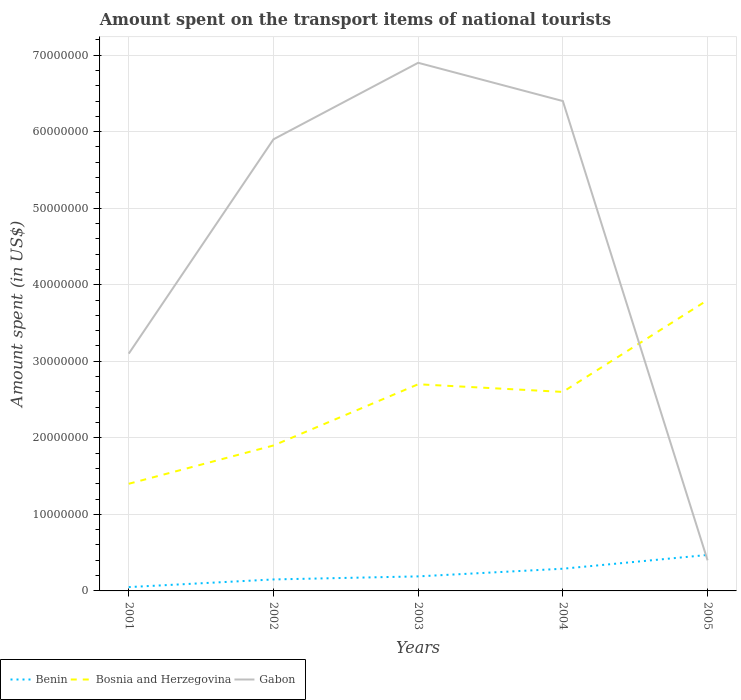How many different coloured lines are there?
Make the answer very short. 3. Does the line corresponding to Benin intersect with the line corresponding to Gabon?
Your answer should be compact. Yes. What is the total amount spent on the transport items of national tourists in Benin in the graph?
Keep it short and to the point. -2.40e+06. What is the difference between the highest and the second highest amount spent on the transport items of national tourists in Benin?
Offer a very short reply. 4.20e+06. Is the amount spent on the transport items of national tourists in Gabon strictly greater than the amount spent on the transport items of national tourists in Benin over the years?
Keep it short and to the point. No. How many lines are there?
Offer a very short reply. 3. How many years are there in the graph?
Offer a very short reply. 5. What is the difference between two consecutive major ticks on the Y-axis?
Give a very brief answer. 1.00e+07. Are the values on the major ticks of Y-axis written in scientific E-notation?
Keep it short and to the point. No. Does the graph contain grids?
Offer a terse response. Yes. What is the title of the graph?
Give a very brief answer. Amount spent on the transport items of national tourists. Does "Cyprus" appear as one of the legend labels in the graph?
Keep it short and to the point. No. What is the label or title of the Y-axis?
Make the answer very short. Amount spent (in US$). What is the Amount spent (in US$) in Benin in 2001?
Offer a very short reply. 5.00e+05. What is the Amount spent (in US$) of Bosnia and Herzegovina in 2001?
Make the answer very short. 1.40e+07. What is the Amount spent (in US$) in Gabon in 2001?
Your answer should be compact. 3.10e+07. What is the Amount spent (in US$) in Benin in 2002?
Give a very brief answer. 1.50e+06. What is the Amount spent (in US$) in Bosnia and Herzegovina in 2002?
Your response must be concise. 1.90e+07. What is the Amount spent (in US$) of Gabon in 2002?
Provide a short and direct response. 5.90e+07. What is the Amount spent (in US$) of Benin in 2003?
Provide a succinct answer. 1.90e+06. What is the Amount spent (in US$) of Bosnia and Herzegovina in 2003?
Your answer should be very brief. 2.70e+07. What is the Amount spent (in US$) of Gabon in 2003?
Keep it short and to the point. 6.90e+07. What is the Amount spent (in US$) in Benin in 2004?
Provide a short and direct response. 2.90e+06. What is the Amount spent (in US$) of Bosnia and Herzegovina in 2004?
Your answer should be very brief. 2.60e+07. What is the Amount spent (in US$) of Gabon in 2004?
Your answer should be compact. 6.40e+07. What is the Amount spent (in US$) of Benin in 2005?
Keep it short and to the point. 4.70e+06. What is the Amount spent (in US$) in Bosnia and Herzegovina in 2005?
Offer a terse response. 3.80e+07. What is the Amount spent (in US$) of Gabon in 2005?
Your response must be concise. 4.00e+06. Across all years, what is the maximum Amount spent (in US$) in Benin?
Make the answer very short. 4.70e+06. Across all years, what is the maximum Amount spent (in US$) in Bosnia and Herzegovina?
Provide a short and direct response. 3.80e+07. Across all years, what is the maximum Amount spent (in US$) of Gabon?
Offer a very short reply. 6.90e+07. Across all years, what is the minimum Amount spent (in US$) in Benin?
Provide a succinct answer. 5.00e+05. Across all years, what is the minimum Amount spent (in US$) in Bosnia and Herzegovina?
Give a very brief answer. 1.40e+07. Across all years, what is the minimum Amount spent (in US$) of Gabon?
Provide a succinct answer. 4.00e+06. What is the total Amount spent (in US$) in Benin in the graph?
Your answer should be compact. 1.15e+07. What is the total Amount spent (in US$) of Bosnia and Herzegovina in the graph?
Provide a short and direct response. 1.24e+08. What is the total Amount spent (in US$) of Gabon in the graph?
Ensure brevity in your answer.  2.27e+08. What is the difference between the Amount spent (in US$) of Bosnia and Herzegovina in 2001 and that in 2002?
Keep it short and to the point. -5.00e+06. What is the difference between the Amount spent (in US$) of Gabon in 2001 and that in 2002?
Offer a terse response. -2.80e+07. What is the difference between the Amount spent (in US$) of Benin in 2001 and that in 2003?
Offer a terse response. -1.40e+06. What is the difference between the Amount spent (in US$) of Bosnia and Herzegovina in 2001 and that in 2003?
Make the answer very short. -1.30e+07. What is the difference between the Amount spent (in US$) in Gabon in 2001 and that in 2003?
Ensure brevity in your answer.  -3.80e+07. What is the difference between the Amount spent (in US$) in Benin in 2001 and that in 2004?
Make the answer very short. -2.40e+06. What is the difference between the Amount spent (in US$) in Bosnia and Herzegovina in 2001 and that in 2004?
Provide a succinct answer. -1.20e+07. What is the difference between the Amount spent (in US$) of Gabon in 2001 and that in 2004?
Your answer should be compact. -3.30e+07. What is the difference between the Amount spent (in US$) of Benin in 2001 and that in 2005?
Your answer should be very brief. -4.20e+06. What is the difference between the Amount spent (in US$) of Bosnia and Herzegovina in 2001 and that in 2005?
Provide a succinct answer. -2.40e+07. What is the difference between the Amount spent (in US$) of Gabon in 2001 and that in 2005?
Offer a terse response. 2.70e+07. What is the difference between the Amount spent (in US$) in Benin in 2002 and that in 2003?
Your answer should be compact. -4.00e+05. What is the difference between the Amount spent (in US$) in Bosnia and Herzegovina in 2002 and that in 2003?
Your response must be concise. -8.00e+06. What is the difference between the Amount spent (in US$) of Gabon in 2002 and that in 2003?
Give a very brief answer. -1.00e+07. What is the difference between the Amount spent (in US$) of Benin in 2002 and that in 2004?
Provide a succinct answer. -1.40e+06. What is the difference between the Amount spent (in US$) of Bosnia and Herzegovina in 2002 and that in 2004?
Keep it short and to the point. -7.00e+06. What is the difference between the Amount spent (in US$) in Gabon in 2002 and that in 2004?
Make the answer very short. -5.00e+06. What is the difference between the Amount spent (in US$) in Benin in 2002 and that in 2005?
Provide a short and direct response. -3.20e+06. What is the difference between the Amount spent (in US$) in Bosnia and Herzegovina in 2002 and that in 2005?
Your answer should be very brief. -1.90e+07. What is the difference between the Amount spent (in US$) in Gabon in 2002 and that in 2005?
Your answer should be compact. 5.50e+07. What is the difference between the Amount spent (in US$) in Bosnia and Herzegovina in 2003 and that in 2004?
Your response must be concise. 1.00e+06. What is the difference between the Amount spent (in US$) in Gabon in 2003 and that in 2004?
Your answer should be compact. 5.00e+06. What is the difference between the Amount spent (in US$) of Benin in 2003 and that in 2005?
Your response must be concise. -2.80e+06. What is the difference between the Amount spent (in US$) in Bosnia and Herzegovina in 2003 and that in 2005?
Ensure brevity in your answer.  -1.10e+07. What is the difference between the Amount spent (in US$) in Gabon in 2003 and that in 2005?
Ensure brevity in your answer.  6.50e+07. What is the difference between the Amount spent (in US$) in Benin in 2004 and that in 2005?
Make the answer very short. -1.80e+06. What is the difference between the Amount spent (in US$) in Bosnia and Herzegovina in 2004 and that in 2005?
Give a very brief answer. -1.20e+07. What is the difference between the Amount spent (in US$) in Gabon in 2004 and that in 2005?
Your answer should be very brief. 6.00e+07. What is the difference between the Amount spent (in US$) of Benin in 2001 and the Amount spent (in US$) of Bosnia and Herzegovina in 2002?
Offer a very short reply. -1.85e+07. What is the difference between the Amount spent (in US$) in Benin in 2001 and the Amount spent (in US$) in Gabon in 2002?
Your answer should be very brief. -5.85e+07. What is the difference between the Amount spent (in US$) of Bosnia and Herzegovina in 2001 and the Amount spent (in US$) of Gabon in 2002?
Offer a terse response. -4.50e+07. What is the difference between the Amount spent (in US$) of Benin in 2001 and the Amount spent (in US$) of Bosnia and Herzegovina in 2003?
Provide a short and direct response. -2.65e+07. What is the difference between the Amount spent (in US$) in Benin in 2001 and the Amount spent (in US$) in Gabon in 2003?
Give a very brief answer. -6.85e+07. What is the difference between the Amount spent (in US$) in Bosnia and Herzegovina in 2001 and the Amount spent (in US$) in Gabon in 2003?
Provide a short and direct response. -5.50e+07. What is the difference between the Amount spent (in US$) in Benin in 2001 and the Amount spent (in US$) in Bosnia and Herzegovina in 2004?
Your response must be concise. -2.55e+07. What is the difference between the Amount spent (in US$) of Benin in 2001 and the Amount spent (in US$) of Gabon in 2004?
Ensure brevity in your answer.  -6.35e+07. What is the difference between the Amount spent (in US$) in Bosnia and Herzegovina in 2001 and the Amount spent (in US$) in Gabon in 2004?
Make the answer very short. -5.00e+07. What is the difference between the Amount spent (in US$) of Benin in 2001 and the Amount spent (in US$) of Bosnia and Herzegovina in 2005?
Offer a terse response. -3.75e+07. What is the difference between the Amount spent (in US$) in Benin in 2001 and the Amount spent (in US$) in Gabon in 2005?
Offer a very short reply. -3.50e+06. What is the difference between the Amount spent (in US$) in Bosnia and Herzegovina in 2001 and the Amount spent (in US$) in Gabon in 2005?
Offer a very short reply. 1.00e+07. What is the difference between the Amount spent (in US$) in Benin in 2002 and the Amount spent (in US$) in Bosnia and Herzegovina in 2003?
Your response must be concise. -2.55e+07. What is the difference between the Amount spent (in US$) of Benin in 2002 and the Amount spent (in US$) of Gabon in 2003?
Your response must be concise. -6.75e+07. What is the difference between the Amount spent (in US$) of Bosnia and Herzegovina in 2002 and the Amount spent (in US$) of Gabon in 2003?
Offer a very short reply. -5.00e+07. What is the difference between the Amount spent (in US$) of Benin in 2002 and the Amount spent (in US$) of Bosnia and Herzegovina in 2004?
Ensure brevity in your answer.  -2.45e+07. What is the difference between the Amount spent (in US$) of Benin in 2002 and the Amount spent (in US$) of Gabon in 2004?
Keep it short and to the point. -6.25e+07. What is the difference between the Amount spent (in US$) of Bosnia and Herzegovina in 2002 and the Amount spent (in US$) of Gabon in 2004?
Give a very brief answer. -4.50e+07. What is the difference between the Amount spent (in US$) of Benin in 2002 and the Amount spent (in US$) of Bosnia and Herzegovina in 2005?
Offer a very short reply. -3.65e+07. What is the difference between the Amount spent (in US$) of Benin in 2002 and the Amount spent (in US$) of Gabon in 2005?
Offer a terse response. -2.50e+06. What is the difference between the Amount spent (in US$) in Bosnia and Herzegovina in 2002 and the Amount spent (in US$) in Gabon in 2005?
Provide a short and direct response. 1.50e+07. What is the difference between the Amount spent (in US$) in Benin in 2003 and the Amount spent (in US$) in Bosnia and Herzegovina in 2004?
Provide a short and direct response. -2.41e+07. What is the difference between the Amount spent (in US$) in Benin in 2003 and the Amount spent (in US$) in Gabon in 2004?
Give a very brief answer. -6.21e+07. What is the difference between the Amount spent (in US$) in Bosnia and Herzegovina in 2003 and the Amount spent (in US$) in Gabon in 2004?
Keep it short and to the point. -3.70e+07. What is the difference between the Amount spent (in US$) in Benin in 2003 and the Amount spent (in US$) in Bosnia and Herzegovina in 2005?
Ensure brevity in your answer.  -3.61e+07. What is the difference between the Amount spent (in US$) in Benin in 2003 and the Amount spent (in US$) in Gabon in 2005?
Keep it short and to the point. -2.10e+06. What is the difference between the Amount spent (in US$) of Bosnia and Herzegovina in 2003 and the Amount spent (in US$) of Gabon in 2005?
Provide a succinct answer. 2.30e+07. What is the difference between the Amount spent (in US$) of Benin in 2004 and the Amount spent (in US$) of Bosnia and Herzegovina in 2005?
Your answer should be very brief. -3.51e+07. What is the difference between the Amount spent (in US$) of Benin in 2004 and the Amount spent (in US$) of Gabon in 2005?
Give a very brief answer. -1.10e+06. What is the difference between the Amount spent (in US$) in Bosnia and Herzegovina in 2004 and the Amount spent (in US$) in Gabon in 2005?
Offer a terse response. 2.20e+07. What is the average Amount spent (in US$) in Benin per year?
Offer a terse response. 2.30e+06. What is the average Amount spent (in US$) of Bosnia and Herzegovina per year?
Give a very brief answer. 2.48e+07. What is the average Amount spent (in US$) of Gabon per year?
Keep it short and to the point. 4.54e+07. In the year 2001, what is the difference between the Amount spent (in US$) of Benin and Amount spent (in US$) of Bosnia and Herzegovina?
Offer a very short reply. -1.35e+07. In the year 2001, what is the difference between the Amount spent (in US$) in Benin and Amount spent (in US$) in Gabon?
Your response must be concise. -3.05e+07. In the year 2001, what is the difference between the Amount spent (in US$) of Bosnia and Herzegovina and Amount spent (in US$) of Gabon?
Your answer should be compact. -1.70e+07. In the year 2002, what is the difference between the Amount spent (in US$) of Benin and Amount spent (in US$) of Bosnia and Herzegovina?
Ensure brevity in your answer.  -1.75e+07. In the year 2002, what is the difference between the Amount spent (in US$) in Benin and Amount spent (in US$) in Gabon?
Give a very brief answer. -5.75e+07. In the year 2002, what is the difference between the Amount spent (in US$) in Bosnia and Herzegovina and Amount spent (in US$) in Gabon?
Offer a terse response. -4.00e+07. In the year 2003, what is the difference between the Amount spent (in US$) of Benin and Amount spent (in US$) of Bosnia and Herzegovina?
Your response must be concise. -2.51e+07. In the year 2003, what is the difference between the Amount spent (in US$) in Benin and Amount spent (in US$) in Gabon?
Your answer should be very brief. -6.71e+07. In the year 2003, what is the difference between the Amount spent (in US$) of Bosnia and Herzegovina and Amount spent (in US$) of Gabon?
Your answer should be compact. -4.20e+07. In the year 2004, what is the difference between the Amount spent (in US$) in Benin and Amount spent (in US$) in Bosnia and Herzegovina?
Your answer should be very brief. -2.31e+07. In the year 2004, what is the difference between the Amount spent (in US$) of Benin and Amount spent (in US$) of Gabon?
Give a very brief answer. -6.11e+07. In the year 2004, what is the difference between the Amount spent (in US$) in Bosnia and Herzegovina and Amount spent (in US$) in Gabon?
Your answer should be compact. -3.80e+07. In the year 2005, what is the difference between the Amount spent (in US$) of Benin and Amount spent (in US$) of Bosnia and Herzegovina?
Offer a terse response. -3.33e+07. In the year 2005, what is the difference between the Amount spent (in US$) in Bosnia and Herzegovina and Amount spent (in US$) in Gabon?
Provide a succinct answer. 3.40e+07. What is the ratio of the Amount spent (in US$) in Bosnia and Herzegovina in 2001 to that in 2002?
Your answer should be very brief. 0.74. What is the ratio of the Amount spent (in US$) of Gabon in 2001 to that in 2002?
Ensure brevity in your answer.  0.53. What is the ratio of the Amount spent (in US$) in Benin in 2001 to that in 2003?
Provide a short and direct response. 0.26. What is the ratio of the Amount spent (in US$) in Bosnia and Herzegovina in 2001 to that in 2003?
Keep it short and to the point. 0.52. What is the ratio of the Amount spent (in US$) in Gabon in 2001 to that in 2003?
Keep it short and to the point. 0.45. What is the ratio of the Amount spent (in US$) in Benin in 2001 to that in 2004?
Provide a succinct answer. 0.17. What is the ratio of the Amount spent (in US$) in Bosnia and Herzegovina in 2001 to that in 2004?
Your answer should be compact. 0.54. What is the ratio of the Amount spent (in US$) of Gabon in 2001 to that in 2004?
Ensure brevity in your answer.  0.48. What is the ratio of the Amount spent (in US$) in Benin in 2001 to that in 2005?
Give a very brief answer. 0.11. What is the ratio of the Amount spent (in US$) of Bosnia and Herzegovina in 2001 to that in 2005?
Your response must be concise. 0.37. What is the ratio of the Amount spent (in US$) of Gabon in 2001 to that in 2005?
Offer a very short reply. 7.75. What is the ratio of the Amount spent (in US$) of Benin in 2002 to that in 2003?
Offer a very short reply. 0.79. What is the ratio of the Amount spent (in US$) in Bosnia and Herzegovina in 2002 to that in 2003?
Your answer should be very brief. 0.7. What is the ratio of the Amount spent (in US$) in Gabon in 2002 to that in 2003?
Offer a terse response. 0.86. What is the ratio of the Amount spent (in US$) in Benin in 2002 to that in 2004?
Provide a short and direct response. 0.52. What is the ratio of the Amount spent (in US$) of Bosnia and Herzegovina in 2002 to that in 2004?
Make the answer very short. 0.73. What is the ratio of the Amount spent (in US$) in Gabon in 2002 to that in 2004?
Ensure brevity in your answer.  0.92. What is the ratio of the Amount spent (in US$) in Benin in 2002 to that in 2005?
Keep it short and to the point. 0.32. What is the ratio of the Amount spent (in US$) of Gabon in 2002 to that in 2005?
Ensure brevity in your answer.  14.75. What is the ratio of the Amount spent (in US$) of Benin in 2003 to that in 2004?
Provide a short and direct response. 0.66. What is the ratio of the Amount spent (in US$) of Gabon in 2003 to that in 2004?
Make the answer very short. 1.08. What is the ratio of the Amount spent (in US$) in Benin in 2003 to that in 2005?
Offer a terse response. 0.4. What is the ratio of the Amount spent (in US$) in Bosnia and Herzegovina in 2003 to that in 2005?
Your answer should be very brief. 0.71. What is the ratio of the Amount spent (in US$) in Gabon in 2003 to that in 2005?
Offer a terse response. 17.25. What is the ratio of the Amount spent (in US$) in Benin in 2004 to that in 2005?
Provide a succinct answer. 0.62. What is the ratio of the Amount spent (in US$) of Bosnia and Herzegovina in 2004 to that in 2005?
Give a very brief answer. 0.68. What is the difference between the highest and the second highest Amount spent (in US$) of Benin?
Provide a short and direct response. 1.80e+06. What is the difference between the highest and the second highest Amount spent (in US$) in Bosnia and Herzegovina?
Your answer should be very brief. 1.10e+07. What is the difference between the highest and the lowest Amount spent (in US$) of Benin?
Keep it short and to the point. 4.20e+06. What is the difference between the highest and the lowest Amount spent (in US$) in Bosnia and Herzegovina?
Your response must be concise. 2.40e+07. What is the difference between the highest and the lowest Amount spent (in US$) of Gabon?
Provide a succinct answer. 6.50e+07. 